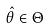Convert formula to latex. <formula><loc_0><loc_0><loc_500><loc_500>\hat { \theta } \in \Theta</formula> 